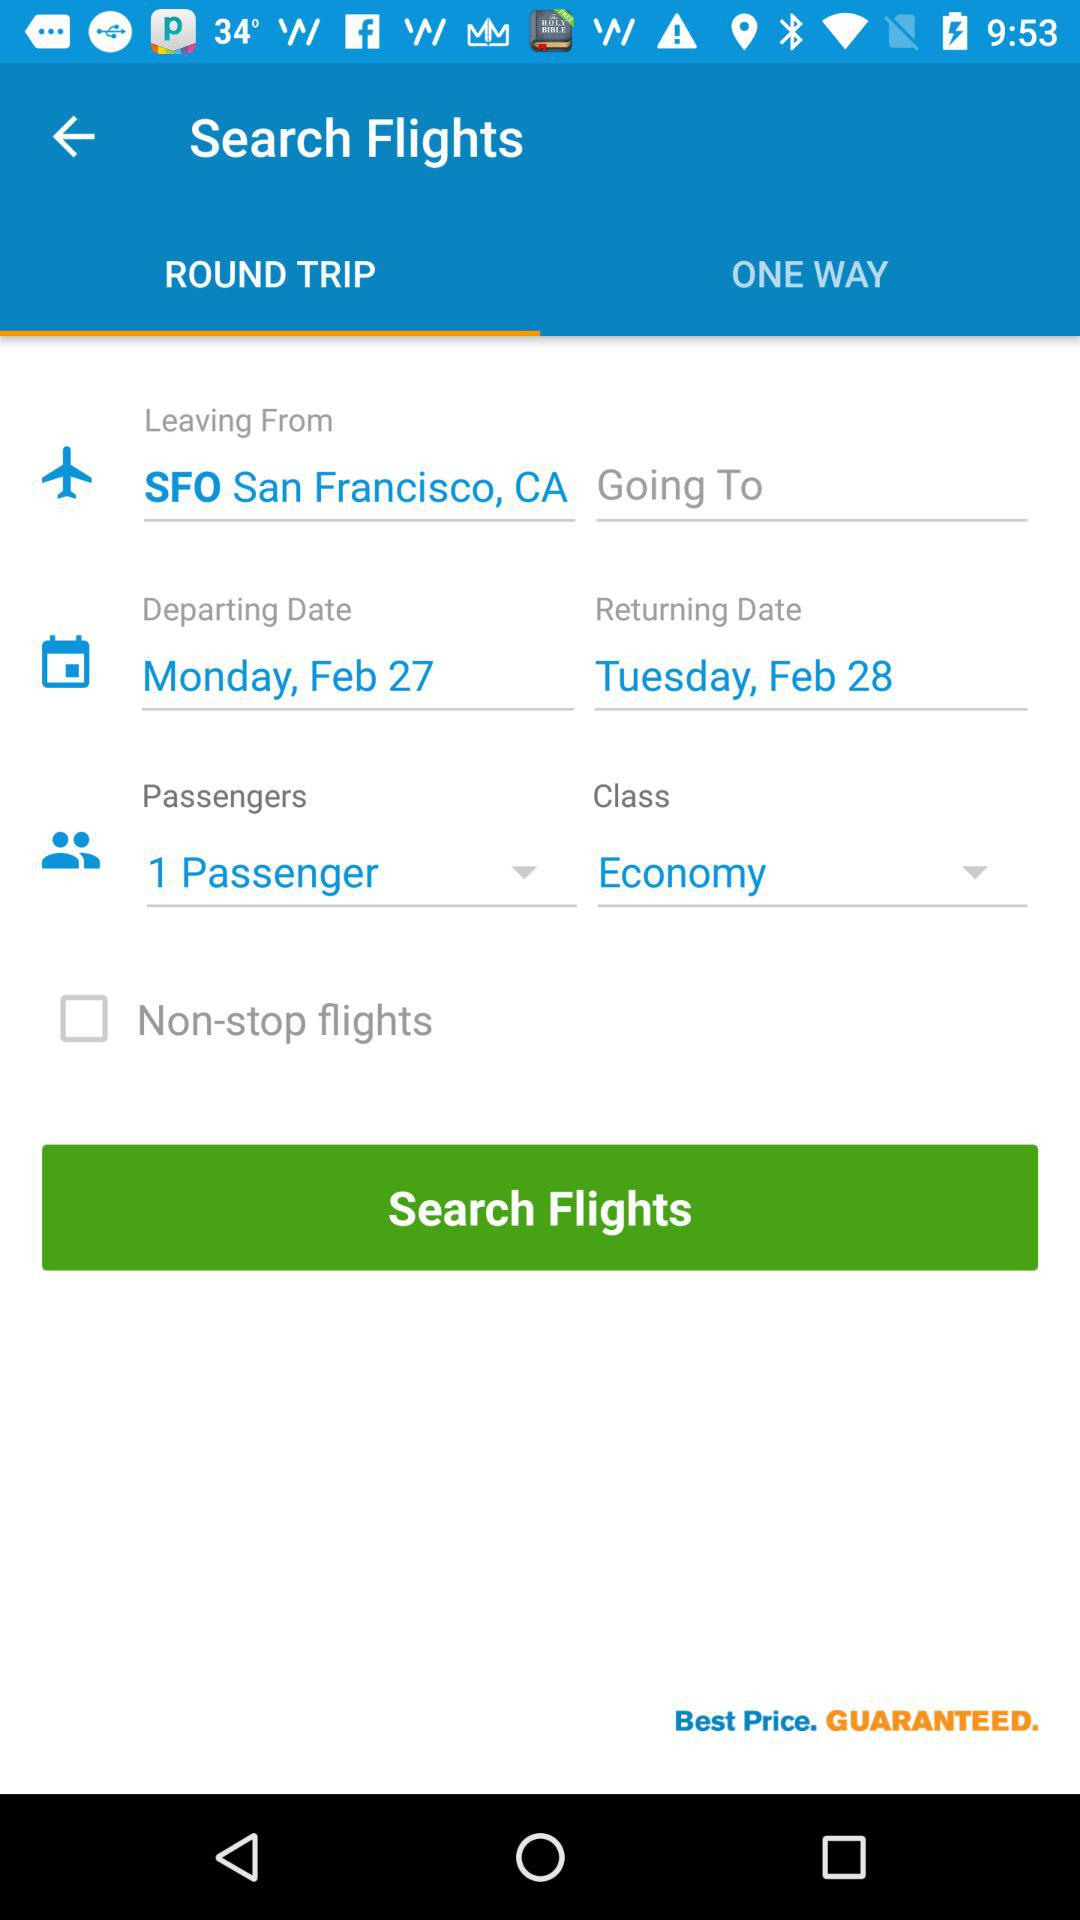What is the travel class? The travel class is "Economy". 